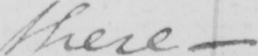What text is written in this handwritten line? these 